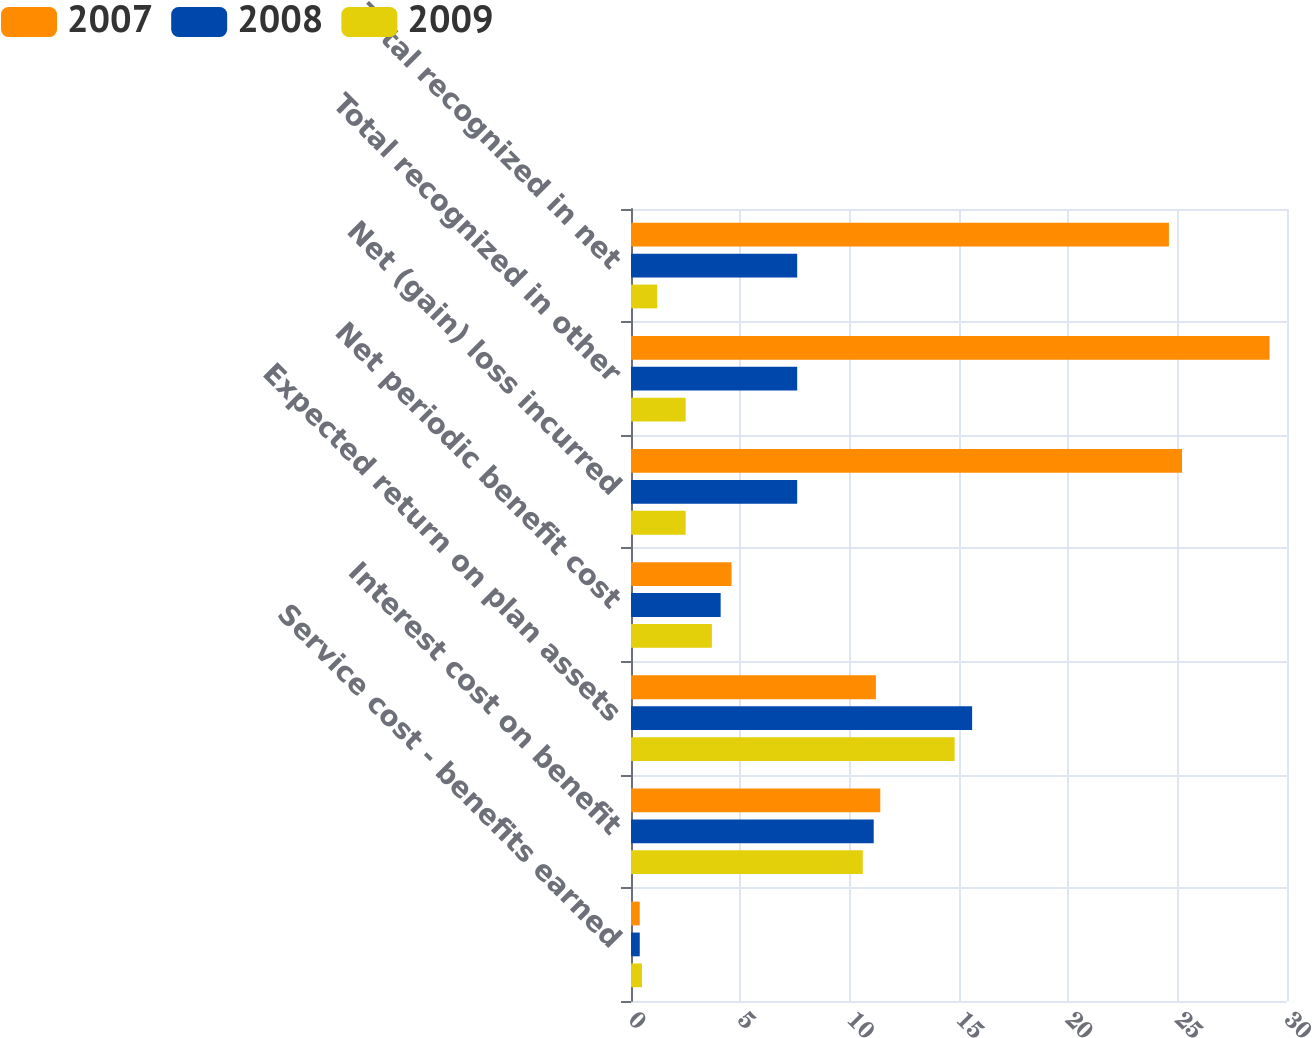Convert chart. <chart><loc_0><loc_0><loc_500><loc_500><stacked_bar_chart><ecel><fcel>Service cost - benefits earned<fcel>Interest cost on benefit<fcel>Expected return on plan assets<fcel>Net periodic benefit cost<fcel>Net (gain) loss incurred<fcel>Total recognized in other<fcel>Total recognized in net<nl><fcel>2007<fcel>0.4<fcel>11.4<fcel>11.2<fcel>4.6<fcel>25.2<fcel>29.2<fcel>24.6<nl><fcel>2008<fcel>0.4<fcel>11.1<fcel>15.6<fcel>4.1<fcel>7.6<fcel>7.6<fcel>7.6<nl><fcel>2009<fcel>0.5<fcel>10.6<fcel>14.8<fcel>3.7<fcel>2.5<fcel>2.5<fcel>1.2<nl></chart> 